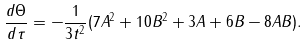<formula> <loc_0><loc_0><loc_500><loc_500>\frac { d \Theta } { d \tau } = - \frac { 1 } { 3 t ^ { 2 } } ( 7 A ^ { 2 } + 1 0 B ^ { 2 } + 3 A + 6 B - 8 A B ) .</formula> 